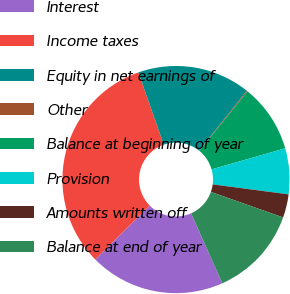Convert chart to OTSL. <chart><loc_0><loc_0><loc_500><loc_500><pie_chart><fcel>Interest<fcel>Income taxes<fcel>Equity in net earnings of<fcel>Other<fcel>Balance at beginning of year<fcel>Provision<fcel>Amounts written off<fcel>Balance at end of year<nl><fcel>19.28%<fcel>32.03%<fcel>16.09%<fcel>0.14%<fcel>9.71%<fcel>6.52%<fcel>3.33%<fcel>12.9%<nl></chart> 